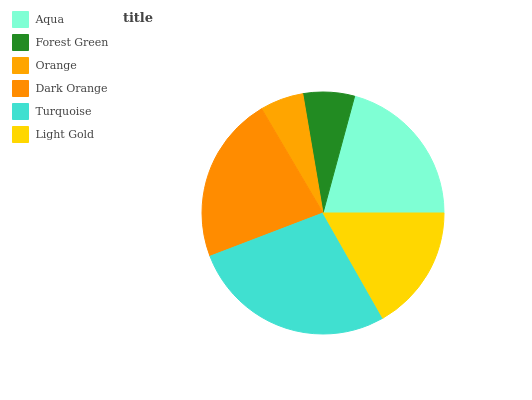Is Orange the minimum?
Answer yes or no. Yes. Is Turquoise the maximum?
Answer yes or no. Yes. Is Forest Green the minimum?
Answer yes or no. No. Is Forest Green the maximum?
Answer yes or no. No. Is Aqua greater than Forest Green?
Answer yes or no. Yes. Is Forest Green less than Aqua?
Answer yes or no. Yes. Is Forest Green greater than Aqua?
Answer yes or no. No. Is Aqua less than Forest Green?
Answer yes or no. No. Is Aqua the high median?
Answer yes or no. Yes. Is Light Gold the low median?
Answer yes or no. Yes. Is Dark Orange the high median?
Answer yes or no. No. Is Dark Orange the low median?
Answer yes or no. No. 